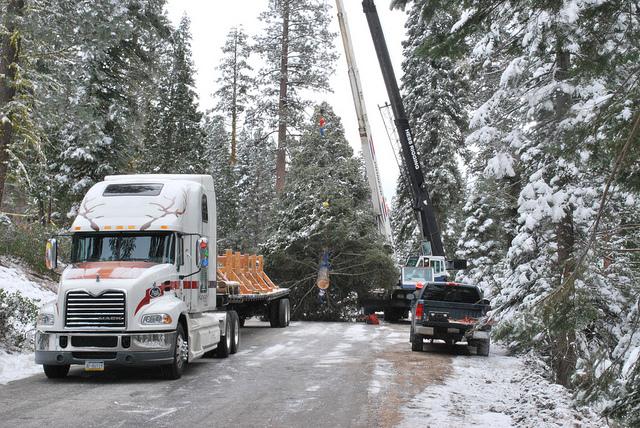What is written on the truck?
Answer briefly. Nothing. How many cars are visible?
Write a very short answer. 1. What color is the truck on the left?
Short answer required. White. Can you see snow?
Write a very short answer. Yes. 